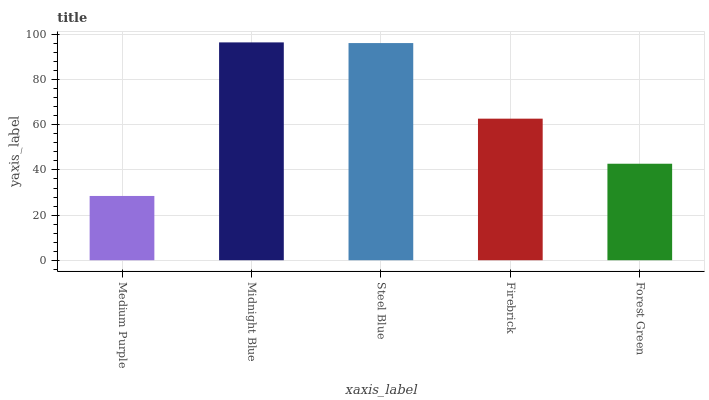Is Medium Purple the minimum?
Answer yes or no. Yes. Is Midnight Blue the maximum?
Answer yes or no. Yes. Is Steel Blue the minimum?
Answer yes or no. No. Is Steel Blue the maximum?
Answer yes or no. No. Is Midnight Blue greater than Steel Blue?
Answer yes or no. Yes. Is Steel Blue less than Midnight Blue?
Answer yes or no. Yes. Is Steel Blue greater than Midnight Blue?
Answer yes or no. No. Is Midnight Blue less than Steel Blue?
Answer yes or no. No. Is Firebrick the high median?
Answer yes or no. Yes. Is Firebrick the low median?
Answer yes or no. Yes. Is Medium Purple the high median?
Answer yes or no. No. Is Medium Purple the low median?
Answer yes or no. No. 